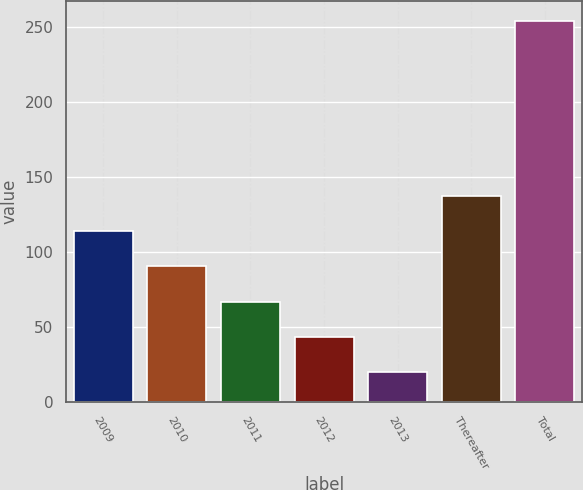Convert chart to OTSL. <chart><loc_0><loc_0><loc_500><loc_500><bar_chart><fcel>2009<fcel>2010<fcel>2011<fcel>2012<fcel>2013<fcel>Thereafter<fcel>Total<nl><fcel>113.86<fcel>90.42<fcel>66.98<fcel>43.54<fcel>20.1<fcel>137.3<fcel>254.5<nl></chart> 